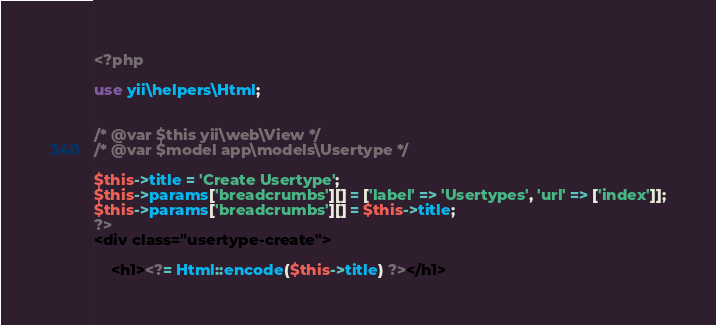Convert code to text. <code><loc_0><loc_0><loc_500><loc_500><_PHP_><?php

use yii\helpers\Html;


/* @var $this yii\web\View */
/* @var $model app\models\Usertype */

$this->title = 'Create Usertype';
$this->params['breadcrumbs'][] = ['label' => 'Usertypes', 'url' => ['index']];
$this->params['breadcrumbs'][] = $this->title;
?>
<div class="usertype-create">

    <h1><?= Html::encode($this->title) ?></h1>
</code> 